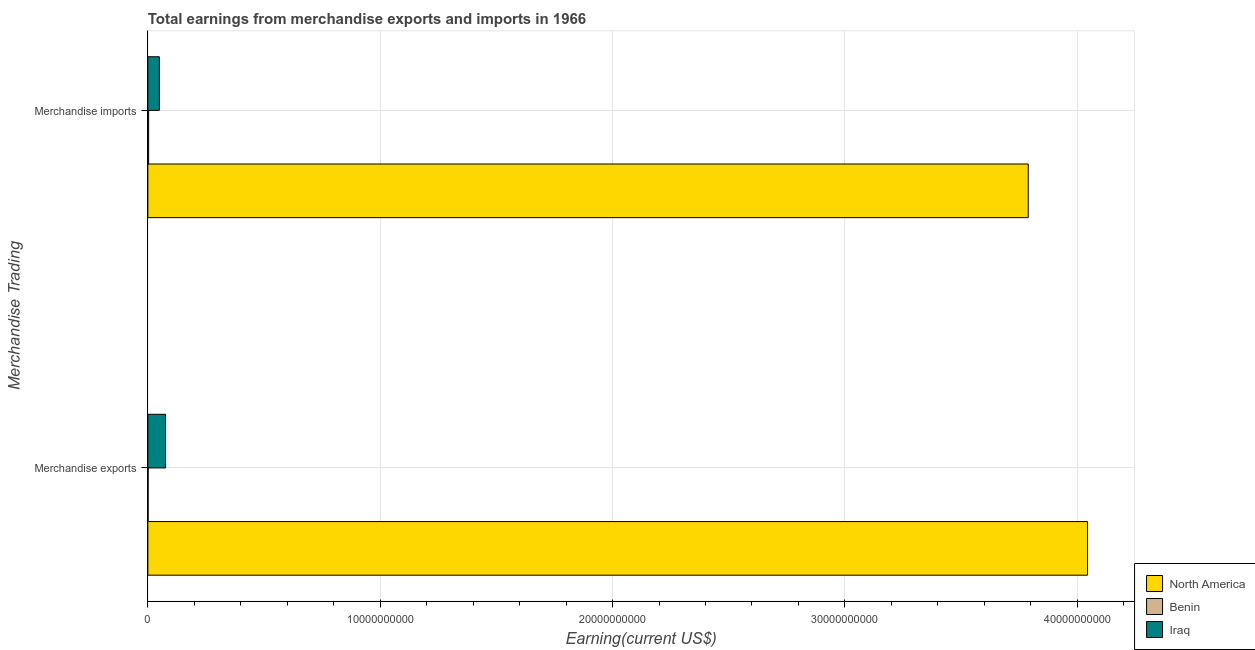How many groups of bars are there?
Offer a terse response. 2. Are the number of bars per tick equal to the number of legend labels?
Your response must be concise. Yes. Are the number of bars on each tick of the Y-axis equal?
Your answer should be very brief. Yes. How many bars are there on the 1st tick from the top?
Make the answer very short. 3. What is the label of the 1st group of bars from the top?
Offer a terse response. Merchandise imports. What is the earnings from merchandise exports in Iraq?
Your response must be concise. 7.63e+08. Across all countries, what is the maximum earnings from merchandise exports?
Provide a short and direct response. 4.04e+1. Across all countries, what is the minimum earnings from merchandise exports?
Offer a terse response. 1.05e+07. In which country was the earnings from merchandise exports maximum?
Your response must be concise. North America. In which country was the earnings from merchandise imports minimum?
Make the answer very short. Benin. What is the total earnings from merchandise imports in the graph?
Offer a terse response. 3.84e+1. What is the difference between the earnings from merchandise imports in Iraq and that in North America?
Provide a short and direct response. -3.74e+1. What is the difference between the earnings from merchandise imports in Iraq and the earnings from merchandise exports in North America?
Ensure brevity in your answer.  -3.99e+1. What is the average earnings from merchandise imports per country?
Your answer should be very brief. 1.28e+1. What is the difference between the earnings from merchandise imports and earnings from merchandise exports in Benin?
Your answer should be very brief. 2.30e+07. What is the ratio of the earnings from merchandise exports in Benin to that in North America?
Your response must be concise. 0. Is the earnings from merchandise exports in Benin less than that in North America?
Keep it short and to the point. Yes. What does the 2nd bar from the top in Merchandise exports represents?
Ensure brevity in your answer.  Benin. What does the 2nd bar from the bottom in Merchandise imports represents?
Provide a succinct answer. Benin. How many bars are there?
Your response must be concise. 6. What is the difference between two consecutive major ticks on the X-axis?
Keep it short and to the point. 1.00e+1. Are the values on the major ticks of X-axis written in scientific E-notation?
Ensure brevity in your answer.  No. Does the graph contain grids?
Keep it short and to the point. Yes. Where does the legend appear in the graph?
Provide a succinct answer. Bottom right. How many legend labels are there?
Offer a very short reply. 3. How are the legend labels stacked?
Keep it short and to the point. Vertical. What is the title of the graph?
Make the answer very short. Total earnings from merchandise exports and imports in 1966. Does "Brunei Darussalam" appear as one of the legend labels in the graph?
Your response must be concise. No. What is the label or title of the X-axis?
Provide a succinct answer. Earning(current US$). What is the label or title of the Y-axis?
Your answer should be very brief. Merchandise Trading. What is the Earning(current US$) of North America in Merchandise exports?
Give a very brief answer. 4.04e+1. What is the Earning(current US$) in Benin in Merchandise exports?
Provide a short and direct response. 1.05e+07. What is the Earning(current US$) of Iraq in Merchandise exports?
Keep it short and to the point. 7.63e+08. What is the Earning(current US$) of North America in Merchandise imports?
Keep it short and to the point. 3.79e+1. What is the Earning(current US$) of Benin in Merchandise imports?
Offer a terse response. 3.35e+07. What is the Earning(current US$) in Iraq in Merchandise imports?
Ensure brevity in your answer.  4.94e+08. Across all Merchandise Trading, what is the maximum Earning(current US$) in North America?
Ensure brevity in your answer.  4.04e+1. Across all Merchandise Trading, what is the maximum Earning(current US$) of Benin?
Your answer should be very brief. 3.35e+07. Across all Merchandise Trading, what is the maximum Earning(current US$) of Iraq?
Give a very brief answer. 7.63e+08. Across all Merchandise Trading, what is the minimum Earning(current US$) in North America?
Offer a terse response. 3.79e+1. Across all Merchandise Trading, what is the minimum Earning(current US$) in Benin?
Provide a short and direct response. 1.05e+07. Across all Merchandise Trading, what is the minimum Earning(current US$) of Iraq?
Provide a short and direct response. 4.94e+08. What is the total Earning(current US$) in North America in the graph?
Provide a short and direct response. 7.83e+1. What is the total Earning(current US$) in Benin in the graph?
Offer a terse response. 4.39e+07. What is the total Earning(current US$) of Iraq in the graph?
Keep it short and to the point. 1.26e+09. What is the difference between the Earning(current US$) in North America in Merchandise exports and that in Merchandise imports?
Your answer should be compact. 2.55e+09. What is the difference between the Earning(current US$) of Benin in Merchandise exports and that in Merchandise imports?
Provide a short and direct response. -2.30e+07. What is the difference between the Earning(current US$) of Iraq in Merchandise exports and that in Merchandise imports?
Provide a succinct answer. 2.69e+08. What is the difference between the Earning(current US$) of North America in Merchandise exports and the Earning(current US$) of Benin in Merchandise imports?
Your response must be concise. 4.04e+1. What is the difference between the Earning(current US$) of North America in Merchandise exports and the Earning(current US$) of Iraq in Merchandise imports?
Your response must be concise. 3.99e+1. What is the difference between the Earning(current US$) of Benin in Merchandise exports and the Earning(current US$) of Iraq in Merchandise imports?
Offer a terse response. -4.84e+08. What is the average Earning(current US$) of North America per Merchandise Trading?
Offer a very short reply. 3.92e+1. What is the average Earning(current US$) in Benin per Merchandise Trading?
Provide a short and direct response. 2.20e+07. What is the average Earning(current US$) of Iraq per Merchandise Trading?
Keep it short and to the point. 6.28e+08. What is the difference between the Earning(current US$) in North America and Earning(current US$) in Benin in Merchandise exports?
Make the answer very short. 4.04e+1. What is the difference between the Earning(current US$) of North America and Earning(current US$) of Iraq in Merchandise exports?
Your answer should be very brief. 3.97e+1. What is the difference between the Earning(current US$) in Benin and Earning(current US$) in Iraq in Merchandise exports?
Your answer should be very brief. -7.53e+08. What is the difference between the Earning(current US$) of North America and Earning(current US$) of Benin in Merchandise imports?
Offer a very short reply. 3.79e+1. What is the difference between the Earning(current US$) of North America and Earning(current US$) of Iraq in Merchandise imports?
Your answer should be very brief. 3.74e+1. What is the difference between the Earning(current US$) in Benin and Earning(current US$) in Iraq in Merchandise imports?
Give a very brief answer. -4.61e+08. What is the ratio of the Earning(current US$) of North America in Merchandise exports to that in Merchandise imports?
Make the answer very short. 1.07. What is the ratio of the Earning(current US$) in Benin in Merchandise exports to that in Merchandise imports?
Ensure brevity in your answer.  0.31. What is the ratio of the Earning(current US$) of Iraq in Merchandise exports to that in Merchandise imports?
Ensure brevity in your answer.  1.54. What is the difference between the highest and the second highest Earning(current US$) in North America?
Offer a terse response. 2.55e+09. What is the difference between the highest and the second highest Earning(current US$) in Benin?
Make the answer very short. 2.30e+07. What is the difference between the highest and the second highest Earning(current US$) of Iraq?
Your answer should be compact. 2.69e+08. What is the difference between the highest and the lowest Earning(current US$) of North America?
Your answer should be compact. 2.55e+09. What is the difference between the highest and the lowest Earning(current US$) in Benin?
Your answer should be very brief. 2.30e+07. What is the difference between the highest and the lowest Earning(current US$) of Iraq?
Your answer should be compact. 2.69e+08. 